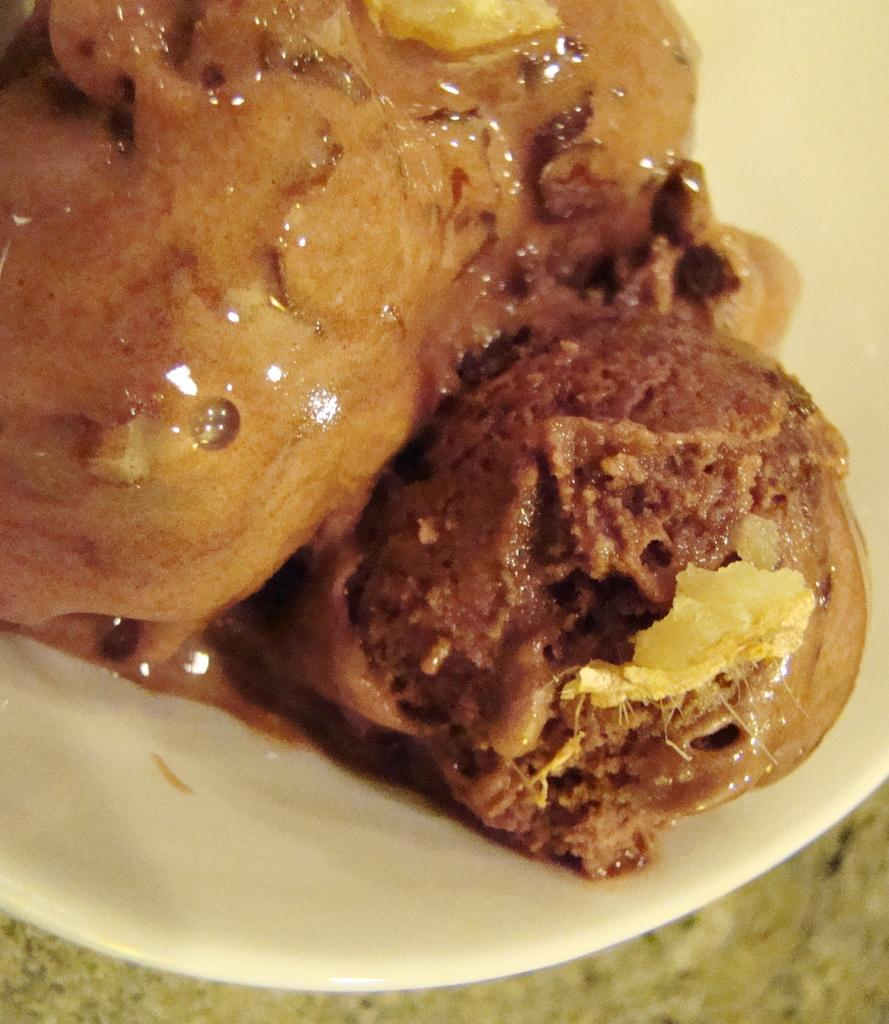What is present in the image related to food? There is food in the image. How is the food arranged or presented? The food is in a plate. Where is the plate with food located? The plate is on a platform. What type of insect can be seen wearing a mask in the image? There is no insect or mask present in the image. How many credits are required to purchase the food in the image? There is no mention of credits or currency in the image, as it only shows food in a plate on a platform. 